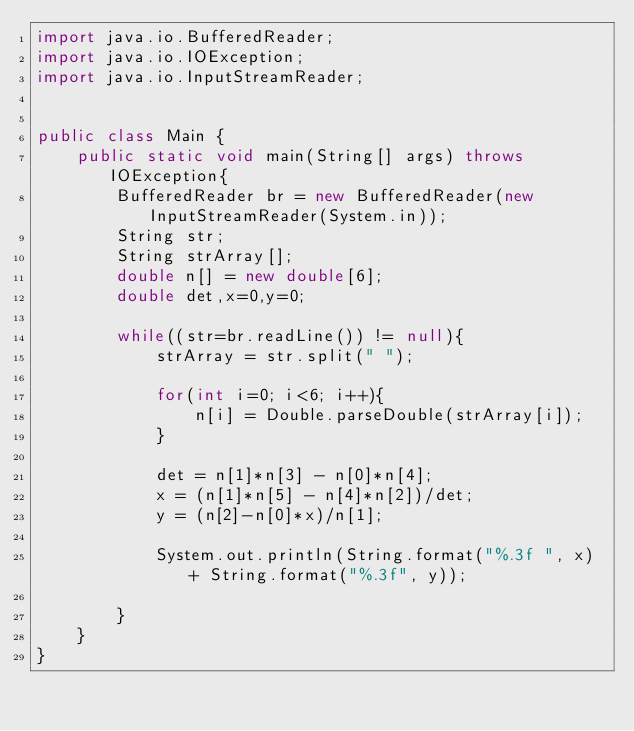Convert code to text. <code><loc_0><loc_0><loc_500><loc_500><_Java_>import java.io.BufferedReader;
import java.io.IOException;
import java.io.InputStreamReader;


public class Main {
	public static void main(String[] args) throws IOException{
		BufferedReader br = new BufferedReader(new InputStreamReader(System.in));
		String str;
		String strArray[];
		double n[] = new double[6];
		double det,x=0,y=0;

		while((str=br.readLine()) != null){
			strArray = str.split(" ");

			for(int i=0; i<6; i++){
				n[i] = Double.parseDouble(strArray[i]);
			}

			det = n[1]*n[3] - n[0]*n[4];
			x = (n[1]*n[5] - n[4]*n[2])/det;
			y = (n[2]-n[0]*x)/n[1];

			System.out.println(String.format("%.3f ", x) + String.format("%.3f", y));

		}
	}
}</code> 